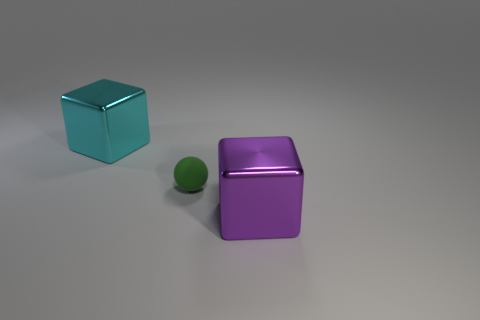Subtract all cyan blocks. How many blocks are left? 1 Subtract all blocks. How many objects are left? 1 Subtract 1 cubes. How many cubes are left? 1 Add 3 spheres. How many objects exist? 6 Subtract all blue balls. Subtract all yellow cylinders. How many balls are left? 1 Subtract all brown spheres. How many green cubes are left? 0 Subtract all metallic blocks. Subtract all tiny gray shiny balls. How many objects are left? 1 Add 2 balls. How many balls are left? 3 Add 1 large red cylinders. How many large red cylinders exist? 1 Subtract 0 green cylinders. How many objects are left? 3 